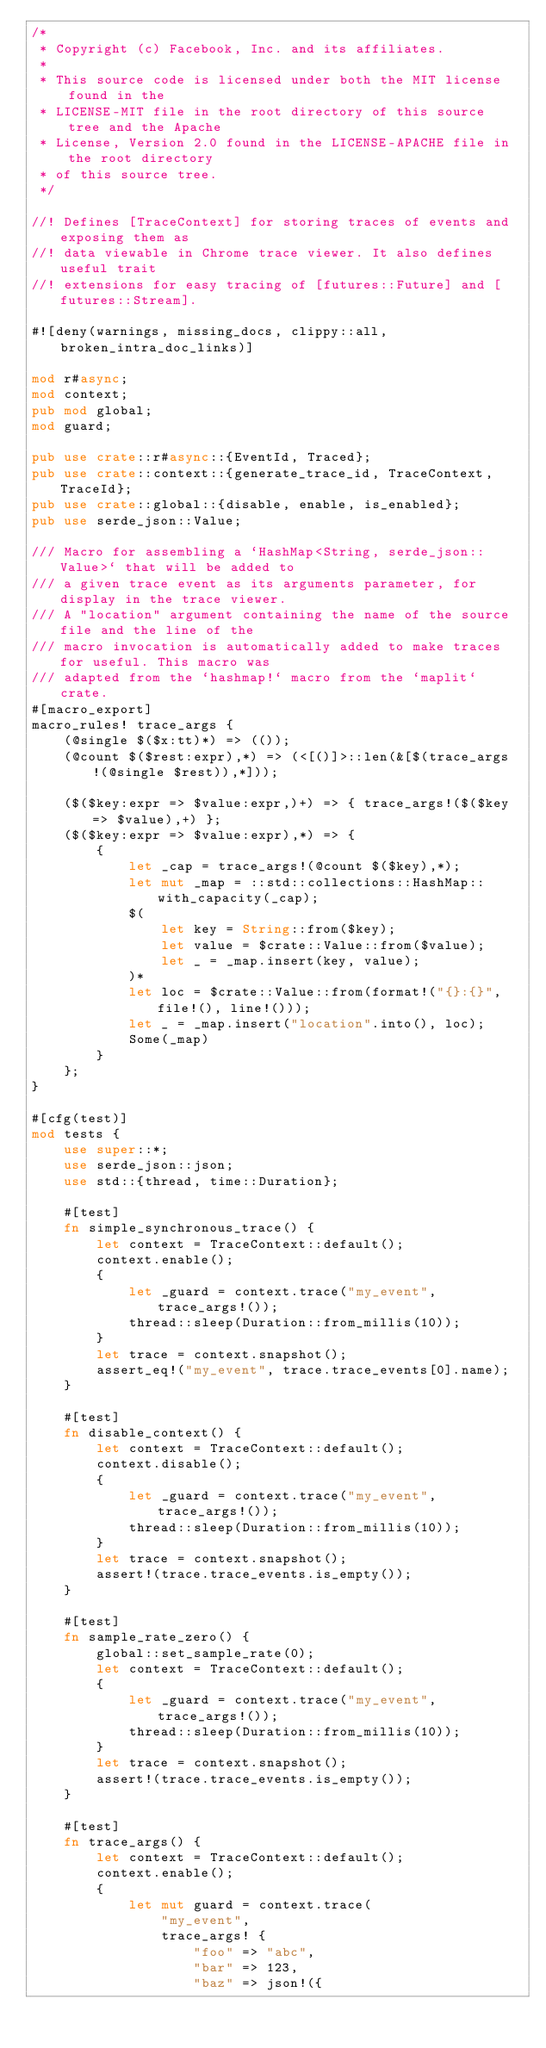Convert code to text. <code><loc_0><loc_0><loc_500><loc_500><_Rust_>/*
 * Copyright (c) Facebook, Inc. and its affiliates.
 *
 * This source code is licensed under both the MIT license found in the
 * LICENSE-MIT file in the root directory of this source tree and the Apache
 * License, Version 2.0 found in the LICENSE-APACHE file in the root directory
 * of this source tree.
 */

//! Defines [TraceContext] for storing traces of events and exposing them as
//! data viewable in Chrome trace viewer. It also defines useful trait
//! extensions for easy tracing of [futures::Future] and [futures::Stream].

#![deny(warnings, missing_docs, clippy::all, broken_intra_doc_links)]

mod r#async;
mod context;
pub mod global;
mod guard;

pub use crate::r#async::{EventId, Traced};
pub use crate::context::{generate_trace_id, TraceContext, TraceId};
pub use crate::global::{disable, enable, is_enabled};
pub use serde_json::Value;

/// Macro for assembling a `HashMap<String, serde_json::Value>` that will be added to
/// a given trace event as its arguments parameter, for display in the trace viewer.
/// A "location" argument containing the name of the source file and the line of the
/// macro invocation is automatically added to make traces for useful. This macro was
/// adapted from the `hashmap!` macro from the `maplit` crate.
#[macro_export]
macro_rules! trace_args {
    (@single $($x:tt)*) => (());
    (@count $($rest:expr),*) => (<[()]>::len(&[$(trace_args!(@single $rest)),*]));

    ($($key:expr => $value:expr,)+) => { trace_args!($($key => $value),+) };
    ($($key:expr => $value:expr),*) => {
        {
            let _cap = trace_args!(@count $($key),*);
            let mut _map = ::std::collections::HashMap::with_capacity(_cap);
            $(
                let key = String::from($key);
                let value = $crate::Value::from($value);
                let _ = _map.insert(key, value);
            )*
            let loc = $crate::Value::from(format!("{}:{}", file!(), line!()));
            let _ = _map.insert("location".into(), loc);
            Some(_map)
        }
    };
}

#[cfg(test)]
mod tests {
    use super::*;
    use serde_json::json;
    use std::{thread, time::Duration};

    #[test]
    fn simple_synchronous_trace() {
        let context = TraceContext::default();
        context.enable();
        {
            let _guard = context.trace("my_event", trace_args!());
            thread::sleep(Duration::from_millis(10));
        }
        let trace = context.snapshot();
        assert_eq!("my_event", trace.trace_events[0].name);
    }

    #[test]
    fn disable_context() {
        let context = TraceContext::default();
        context.disable();
        {
            let _guard = context.trace("my_event", trace_args!());
            thread::sleep(Duration::from_millis(10));
        }
        let trace = context.snapshot();
        assert!(trace.trace_events.is_empty());
    }

    #[test]
    fn sample_rate_zero() {
        global::set_sample_rate(0);
        let context = TraceContext::default();
        {
            let _guard = context.trace("my_event", trace_args!());
            thread::sleep(Duration::from_millis(10));
        }
        let trace = context.snapshot();
        assert!(trace.trace_events.is_empty());
    }

    #[test]
    fn trace_args() {
        let context = TraceContext::default();
        context.enable();
        {
            let mut guard = context.trace(
                "my_event",
                trace_args! {
                    "foo" => "abc",
                    "bar" => 123,
                    "baz" => json!({</code> 